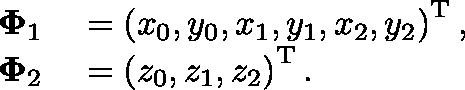<formula> <loc_0><loc_0><loc_500><loc_500>\begin{array} { r l } { \Phi _ { 1 } } & = \left ( x _ { 0 } , y _ { 0 } , x _ { 1 } , y _ { 1 } , x _ { 2 } , y _ { 2 } \right ) ^ { T } , } \\ { \Phi _ { 2 } } & = \left ( z _ { 0 } , z _ { 1 } , z _ { 2 } \right ) ^ { T } . } \end{array}</formula> 